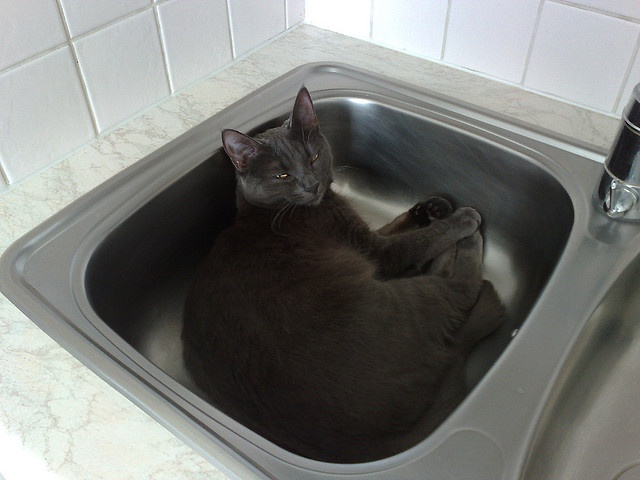Describe the objects in this image and their specific colors. I can see sink in lightgray, black, and gray tones and cat in lightgray, black, and gray tones in this image. 